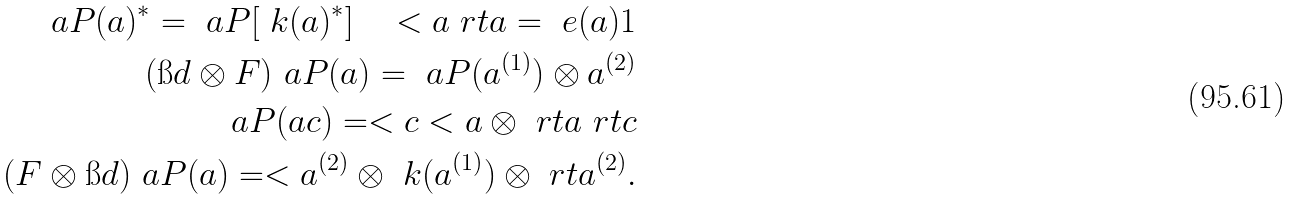Convert formula to latex. <formula><loc_0><loc_0><loc_500><loc_500>\ a P ( a ) ^ { * } = \ a P [ \ k ( a ) ^ { * } ] \quad < { a } \ r t { a } = \ e ( a ) 1 \\ ( \i d \otimes F ) \ a P ( a ) = \ a P ( a ^ { ( 1 ) } ) \otimes a ^ { ( 2 ) } \\ \ a P ( a c ) = < { c } < { a } \otimes \ r t { a } \ r t { c } \\ ( F \otimes \i d ) \ a P ( a ) = < { a ^ { ( 2 ) } } \otimes \ k ( a ^ { ( 1 ) } ) \otimes \ r t { a ^ { ( 2 ) } } .</formula> 